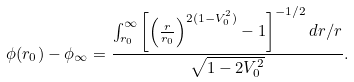Convert formula to latex. <formula><loc_0><loc_0><loc_500><loc_500>\phi ( r _ { 0 } ) - \phi _ { \infty } = \frac { \int _ { r _ { 0 } } ^ { \infty } \left [ \left ( \frac { r } { r _ { 0 } } \right ) ^ { 2 ( 1 - V _ { 0 } ^ { 2 } ) } - 1 \right ] ^ { - 1 / 2 } d r / r } { \sqrt { 1 - 2 V _ { 0 } ^ { 2 } } } .</formula> 